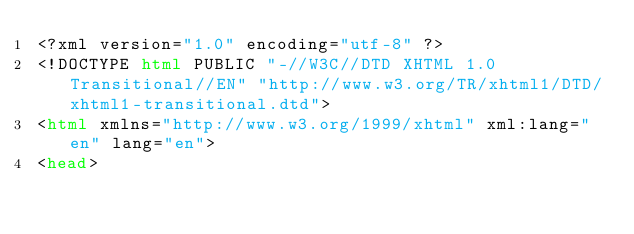Convert code to text. <code><loc_0><loc_0><loc_500><loc_500><_HTML_><?xml version="1.0" encoding="utf-8" ?>
<!DOCTYPE html PUBLIC "-//W3C//DTD XHTML 1.0 Transitional//EN" "http://www.w3.org/TR/xhtml1/DTD/xhtml1-transitional.dtd">
<html xmlns="http://www.w3.org/1999/xhtml" xml:lang="en" lang="en">
<head></code> 